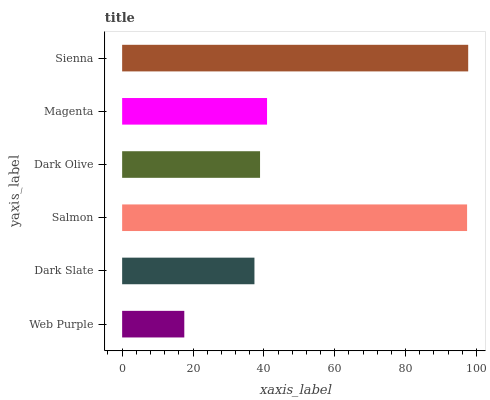Is Web Purple the minimum?
Answer yes or no. Yes. Is Sienna the maximum?
Answer yes or no. Yes. Is Dark Slate the minimum?
Answer yes or no. No. Is Dark Slate the maximum?
Answer yes or no. No. Is Dark Slate greater than Web Purple?
Answer yes or no. Yes. Is Web Purple less than Dark Slate?
Answer yes or no. Yes. Is Web Purple greater than Dark Slate?
Answer yes or no. No. Is Dark Slate less than Web Purple?
Answer yes or no. No. Is Magenta the high median?
Answer yes or no. Yes. Is Dark Olive the low median?
Answer yes or no. Yes. Is Sienna the high median?
Answer yes or no. No. Is Salmon the low median?
Answer yes or no. No. 